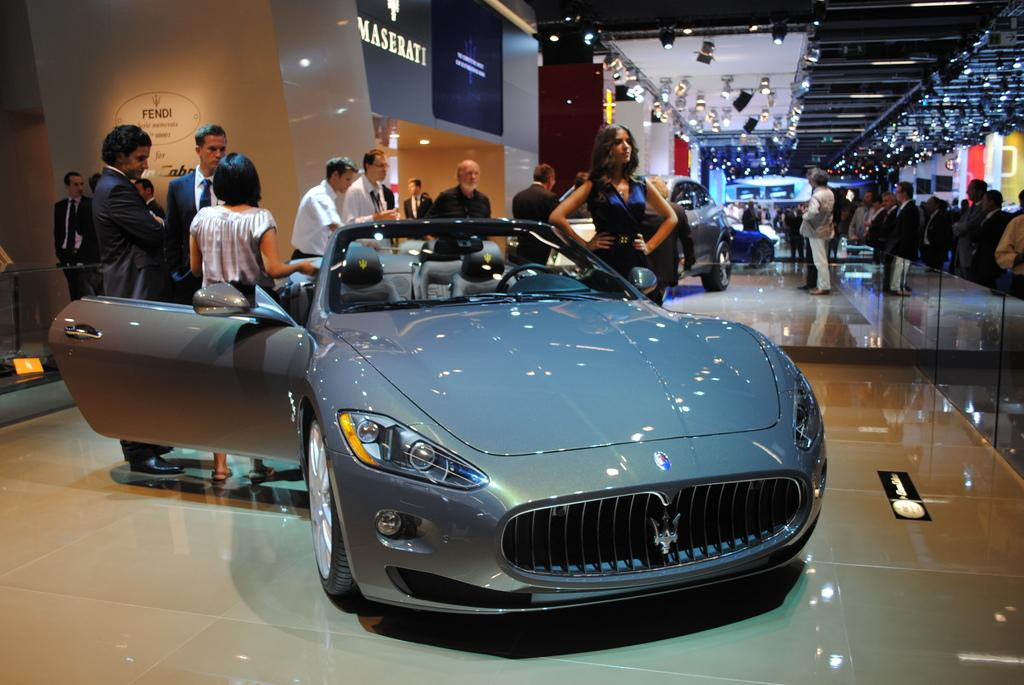What type of vehicles can be seen in the image? There are cars in the image. What are the people in the image doing? There is a group of people standing on the floor. What can be seen in the background of the image? There are lights visible in the background of the image. What type of agreement is being signed by the people in the image? There is no indication in the image that people are signing any agreement. Can you see a ship in the image? No, there is no ship present in the image. 